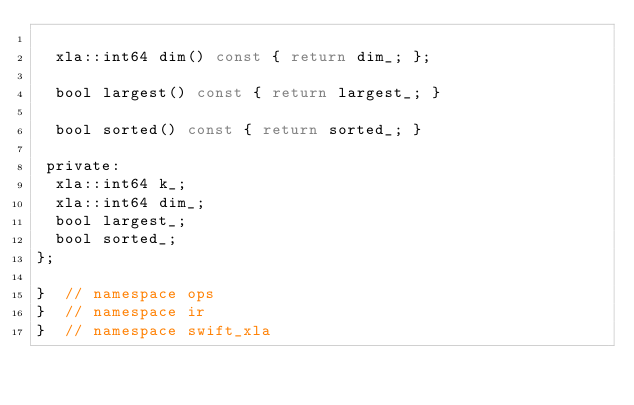<code> <loc_0><loc_0><loc_500><loc_500><_C_>
  xla::int64 dim() const { return dim_; };

  bool largest() const { return largest_; }

  bool sorted() const { return sorted_; }

 private:
  xla::int64 k_;
  xla::int64 dim_;
  bool largest_;
  bool sorted_;
};

}  // namespace ops
}  // namespace ir
}  // namespace swift_xla
</code> 